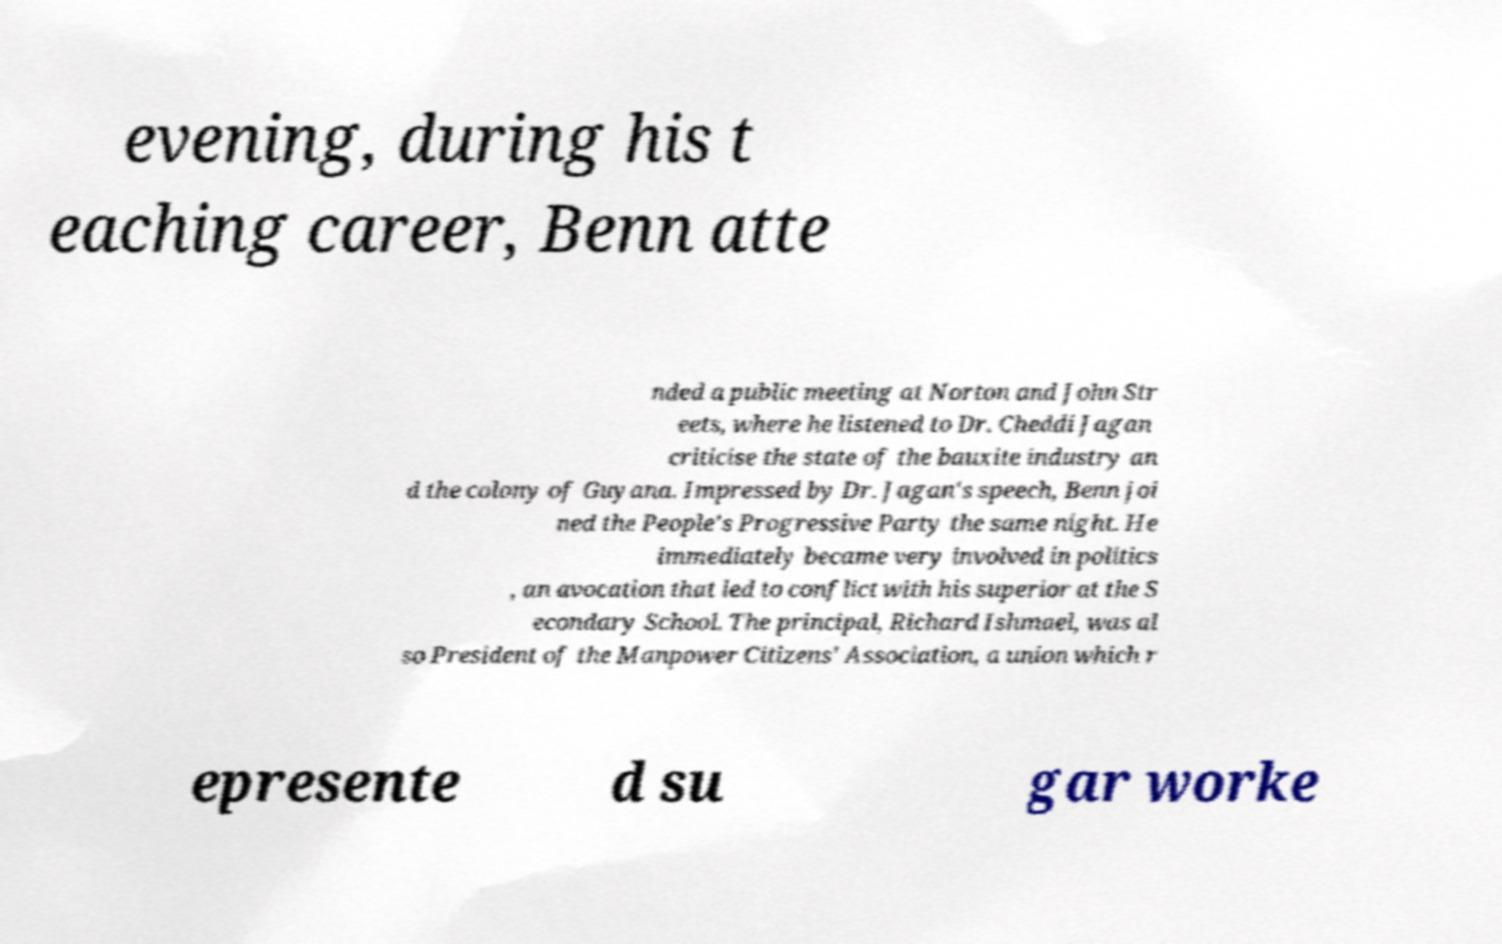What messages or text are displayed in this image? I need them in a readable, typed format. evening, during his t eaching career, Benn atte nded a public meeting at Norton and John Str eets, where he listened to Dr. Cheddi Jagan criticise the state of the bauxite industry an d the colony of Guyana. Impressed by Dr. Jagan's speech, Benn joi ned the People's Progressive Party the same night. He immediately became very involved in politics , an avocation that led to conflict with his superior at the S econdary School. The principal, Richard Ishmael, was al so President of the Manpower Citizens' Association, a union which r epresente d su gar worke 